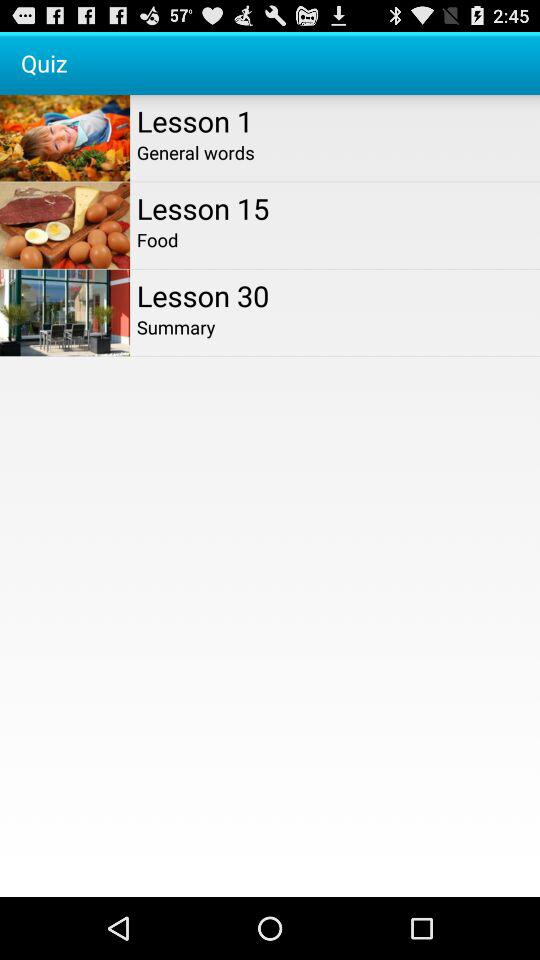Which lesson's name is "Food"? "Food" is the name of Lesson 15. 